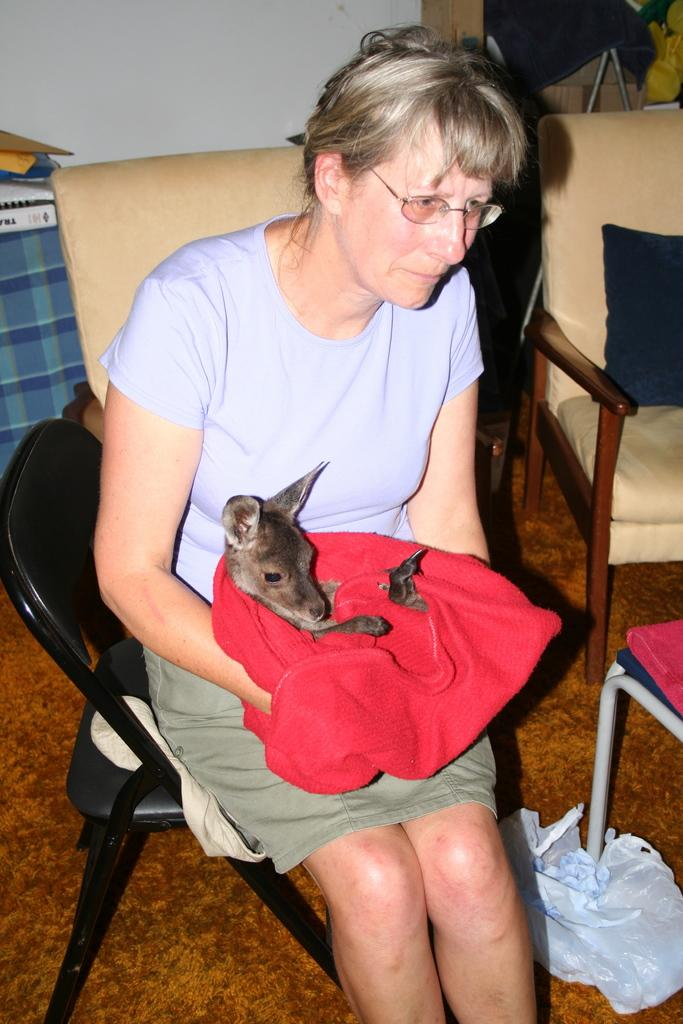Who is the main subject in the image? There is an old lady in the image. What is the old lady doing in the image? The old lady is sitting on a chair. What is the old lady holding in her arms? The old lady is holding a puppy in her arms. What can be seen in the background of the image? There is a couch in the background of the image. What is on the couch in the image? The couch has cushions on it. What color are the shoes worn by the old lady in the image? There is no mention of shoes in the image, so we cannot determine their color. 